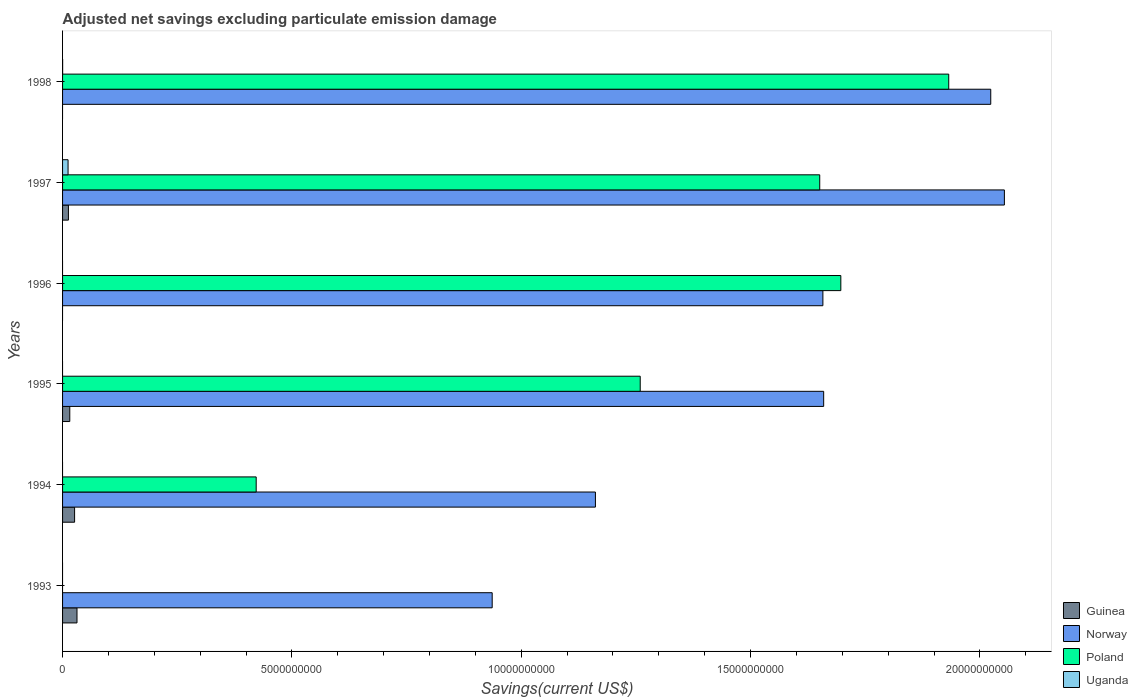Are the number of bars per tick equal to the number of legend labels?
Your answer should be compact. No. Are the number of bars on each tick of the Y-axis equal?
Offer a terse response. No. What is the label of the 1st group of bars from the top?
Keep it short and to the point. 1998. What is the adjusted net savings in Norway in 1996?
Make the answer very short. 1.66e+1. Across all years, what is the maximum adjusted net savings in Uganda?
Keep it short and to the point. 1.20e+08. Across all years, what is the minimum adjusted net savings in Guinea?
Offer a very short reply. 0. In which year was the adjusted net savings in Poland maximum?
Offer a terse response. 1998. What is the total adjusted net savings in Norway in the graph?
Your answer should be very brief. 9.49e+1. What is the difference between the adjusted net savings in Norway in 1994 and that in 1997?
Give a very brief answer. -8.92e+09. What is the difference between the adjusted net savings in Guinea in 1994 and the adjusted net savings in Norway in 1996?
Your answer should be compact. -1.63e+1. What is the average adjusted net savings in Norway per year?
Your response must be concise. 1.58e+1. In the year 1997, what is the difference between the adjusted net savings in Norway and adjusted net savings in Poland?
Your response must be concise. 4.03e+09. What is the ratio of the adjusted net savings in Norway in 1994 to that in 1996?
Give a very brief answer. 0.7. Is the adjusted net savings in Norway in 1994 less than that in 1996?
Ensure brevity in your answer.  Yes. What is the difference between the highest and the second highest adjusted net savings in Guinea?
Ensure brevity in your answer.  5.23e+07. What is the difference between the highest and the lowest adjusted net savings in Uganda?
Your answer should be very brief. 1.20e+08. Is the sum of the adjusted net savings in Guinea in 1994 and 1997 greater than the maximum adjusted net savings in Uganda across all years?
Provide a short and direct response. Yes. Is it the case that in every year, the sum of the adjusted net savings in Uganda and adjusted net savings in Guinea is greater than the sum of adjusted net savings in Poland and adjusted net savings in Norway?
Your response must be concise. No. Is it the case that in every year, the sum of the adjusted net savings in Poland and adjusted net savings in Uganda is greater than the adjusted net savings in Guinea?
Provide a short and direct response. No. Are all the bars in the graph horizontal?
Offer a very short reply. Yes. Does the graph contain any zero values?
Your response must be concise. Yes. What is the title of the graph?
Your response must be concise. Adjusted net savings excluding particulate emission damage. Does "Europe(developing only)" appear as one of the legend labels in the graph?
Keep it short and to the point. No. What is the label or title of the X-axis?
Your answer should be compact. Savings(current US$). What is the Savings(current US$) of Guinea in 1993?
Provide a succinct answer. 3.15e+08. What is the Savings(current US$) in Norway in 1993?
Offer a very short reply. 9.37e+09. What is the Savings(current US$) in Poland in 1993?
Keep it short and to the point. 0. What is the Savings(current US$) of Uganda in 1993?
Your answer should be compact. 0. What is the Savings(current US$) of Guinea in 1994?
Make the answer very short. 2.62e+08. What is the Savings(current US$) in Norway in 1994?
Provide a succinct answer. 1.16e+1. What is the Savings(current US$) of Poland in 1994?
Your answer should be very brief. 4.22e+09. What is the Savings(current US$) of Uganda in 1994?
Provide a succinct answer. 0. What is the Savings(current US$) of Guinea in 1995?
Provide a short and direct response. 1.57e+08. What is the Savings(current US$) in Norway in 1995?
Ensure brevity in your answer.  1.66e+1. What is the Savings(current US$) in Poland in 1995?
Keep it short and to the point. 1.26e+1. What is the Savings(current US$) of Uganda in 1995?
Provide a succinct answer. 0. What is the Savings(current US$) of Norway in 1996?
Your response must be concise. 1.66e+1. What is the Savings(current US$) of Poland in 1996?
Your answer should be compact. 1.70e+1. What is the Savings(current US$) in Guinea in 1997?
Provide a short and direct response. 1.28e+08. What is the Savings(current US$) of Norway in 1997?
Provide a short and direct response. 2.05e+1. What is the Savings(current US$) in Poland in 1997?
Offer a very short reply. 1.65e+1. What is the Savings(current US$) of Uganda in 1997?
Your response must be concise. 1.20e+08. What is the Savings(current US$) in Guinea in 1998?
Ensure brevity in your answer.  0. What is the Savings(current US$) of Norway in 1998?
Offer a very short reply. 2.02e+1. What is the Savings(current US$) of Poland in 1998?
Provide a succinct answer. 1.93e+1. What is the Savings(current US$) in Uganda in 1998?
Provide a succinct answer. 1.28e+06. Across all years, what is the maximum Savings(current US$) of Guinea?
Keep it short and to the point. 3.15e+08. Across all years, what is the maximum Savings(current US$) in Norway?
Make the answer very short. 2.05e+1. Across all years, what is the maximum Savings(current US$) of Poland?
Ensure brevity in your answer.  1.93e+1. Across all years, what is the maximum Savings(current US$) in Uganda?
Offer a terse response. 1.20e+08. Across all years, what is the minimum Savings(current US$) in Norway?
Keep it short and to the point. 9.37e+09. Across all years, what is the minimum Savings(current US$) of Poland?
Offer a very short reply. 0. Across all years, what is the minimum Savings(current US$) of Uganda?
Give a very brief answer. 0. What is the total Savings(current US$) in Guinea in the graph?
Provide a succinct answer. 8.62e+08. What is the total Savings(current US$) in Norway in the graph?
Your answer should be compact. 9.49e+1. What is the total Savings(current US$) in Poland in the graph?
Give a very brief answer. 6.96e+1. What is the total Savings(current US$) in Uganda in the graph?
Your answer should be very brief. 1.21e+08. What is the difference between the Savings(current US$) in Guinea in 1993 and that in 1994?
Make the answer very short. 5.23e+07. What is the difference between the Savings(current US$) of Norway in 1993 and that in 1994?
Ensure brevity in your answer.  -2.25e+09. What is the difference between the Savings(current US$) in Guinea in 1993 and that in 1995?
Make the answer very short. 1.57e+08. What is the difference between the Savings(current US$) of Norway in 1993 and that in 1995?
Your response must be concise. -7.23e+09. What is the difference between the Savings(current US$) in Norway in 1993 and that in 1996?
Keep it short and to the point. -7.21e+09. What is the difference between the Savings(current US$) in Guinea in 1993 and that in 1997?
Your answer should be very brief. 1.87e+08. What is the difference between the Savings(current US$) in Norway in 1993 and that in 1997?
Your answer should be very brief. -1.12e+1. What is the difference between the Savings(current US$) in Norway in 1993 and that in 1998?
Provide a succinct answer. -1.09e+1. What is the difference between the Savings(current US$) in Guinea in 1994 and that in 1995?
Make the answer very short. 1.05e+08. What is the difference between the Savings(current US$) in Norway in 1994 and that in 1995?
Offer a very short reply. -4.98e+09. What is the difference between the Savings(current US$) in Poland in 1994 and that in 1995?
Ensure brevity in your answer.  -8.37e+09. What is the difference between the Savings(current US$) of Norway in 1994 and that in 1996?
Provide a short and direct response. -4.96e+09. What is the difference between the Savings(current US$) in Poland in 1994 and that in 1996?
Ensure brevity in your answer.  -1.27e+1. What is the difference between the Savings(current US$) in Guinea in 1994 and that in 1997?
Provide a succinct answer. 1.35e+08. What is the difference between the Savings(current US$) in Norway in 1994 and that in 1997?
Make the answer very short. -8.92e+09. What is the difference between the Savings(current US$) of Poland in 1994 and that in 1997?
Offer a very short reply. -1.23e+1. What is the difference between the Savings(current US$) in Norway in 1994 and that in 1998?
Your answer should be very brief. -8.62e+09. What is the difference between the Savings(current US$) in Poland in 1994 and that in 1998?
Keep it short and to the point. -1.51e+1. What is the difference between the Savings(current US$) of Norway in 1995 and that in 1996?
Ensure brevity in your answer.  1.71e+07. What is the difference between the Savings(current US$) in Poland in 1995 and that in 1996?
Offer a terse response. -4.37e+09. What is the difference between the Savings(current US$) in Guinea in 1995 and that in 1997?
Provide a succinct answer. 2.96e+07. What is the difference between the Savings(current US$) in Norway in 1995 and that in 1997?
Ensure brevity in your answer.  -3.94e+09. What is the difference between the Savings(current US$) in Poland in 1995 and that in 1997?
Ensure brevity in your answer.  -3.91e+09. What is the difference between the Savings(current US$) in Norway in 1995 and that in 1998?
Your answer should be very brief. -3.64e+09. What is the difference between the Savings(current US$) of Poland in 1995 and that in 1998?
Your response must be concise. -6.73e+09. What is the difference between the Savings(current US$) in Norway in 1996 and that in 1997?
Keep it short and to the point. -3.96e+09. What is the difference between the Savings(current US$) in Poland in 1996 and that in 1997?
Offer a terse response. 4.60e+08. What is the difference between the Savings(current US$) in Norway in 1996 and that in 1998?
Offer a terse response. -3.66e+09. What is the difference between the Savings(current US$) of Poland in 1996 and that in 1998?
Provide a succinct answer. -2.35e+09. What is the difference between the Savings(current US$) in Norway in 1997 and that in 1998?
Make the answer very short. 2.97e+08. What is the difference between the Savings(current US$) of Poland in 1997 and that in 1998?
Your response must be concise. -2.81e+09. What is the difference between the Savings(current US$) of Uganda in 1997 and that in 1998?
Your response must be concise. 1.18e+08. What is the difference between the Savings(current US$) in Guinea in 1993 and the Savings(current US$) in Norway in 1994?
Provide a short and direct response. -1.13e+1. What is the difference between the Savings(current US$) of Guinea in 1993 and the Savings(current US$) of Poland in 1994?
Make the answer very short. -3.91e+09. What is the difference between the Savings(current US$) of Norway in 1993 and the Savings(current US$) of Poland in 1994?
Keep it short and to the point. 5.15e+09. What is the difference between the Savings(current US$) of Guinea in 1993 and the Savings(current US$) of Norway in 1995?
Give a very brief answer. -1.63e+1. What is the difference between the Savings(current US$) in Guinea in 1993 and the Savings(current US$) in Poland in 1995?
Your response must be concise. -1.23e+1. What is the difference between the Savings(current US$) of Norway in 1993 and the Savings(current US$) of Poland in 1995?
Provide a succinct answer. -3.23e+09. What is the difference between the Savings(current US$) of Guinea in 1993 and the Savings(current US$) of Norway in 1996?
Your answer should be very brief. -1.63e+1. What is the difference between the Savings(current US$) of Guinea in 1993 and the Savings(current US$) of Poland in 1996?
Make the answer very short. -1.67e+1. What is the difference between the Savings(current US$) of Norway in 1993 and the Savings(current US$) of Poland in 1996?
Offer a very short reply. -7.60e+09. What is the difference between the Savings(current US$) of Guinea in 1993 and the Savings(current US$) of Norway in 1997?
Ensure brevity in your answer.  -2.02e+1. What is the difference between the Savings(current US$) in Guinea in 1993 and the Savings(current US$) in Poland in 1997?
Provide a succinct answer. -1.62e+1. What is the difference between the Savings(current US$) in Guinea in 1993 and the Savings(current US$) in Uganda in 1997?
Your response must be concise. 1.95e+08. What is the difference between the Savings(current US$) in Norway in 1993 and the Savings(current US$) in Poland in 1997?
Provide a short and direct response. -7.14e+09. What is the difference between the Savings(current US$) in Norway in 1993 and the Savings(current US$) in Uganda in 1997?
Your response must be concise. 9.25e+09. What is the difference between the Savings(current US$) in Guinea in 1993 and the Savings(current US$) in Norway in 1998?
Your answer should be compact. -1.99e+1. What is the difference between the Savings(current US$) in Guinea in 1993 and the Savings(current US$) in Poland in 1998?
Offer a terse response. -1.90e+1. What is the difference between the Savings(current US$) in Guinea in 1993 and the Savings(current US$) in Uganda in 1998?
Ensure brevity in your answer.  3.13e+08. What is the difference between the Savings(current US$) of Norway in 1993 and the Savings(current US$) of Poland in 1998?
Offer a terse response. -9.95e+09. What is the difference between the Savings(current US$) of Norway in 1993 and the Savings(current US$) of Uganda in 1998?
Your answer should be compact. 9.37e+09. What is the difference between the Savings(current US$) in Guinea in 1994 and the Savings(current US$) in Norway in 1995?
Provide a short and direct response. -1.63e+1. What is the difference between the Savings(current US$) of Guinea in 1994 and the Savings(current US$) of Poland in 1995?
Provide a short and direct response. -1.23e+1. What is the difference between the Savings(current US$) in Norway in 1994 and the Savings(current US$) in Poland in 1995?
Offer a terse response. -9.77e+08. What is the difference between the Savings(current US$) of Guinea in 1994 and the Savings(current US$) of Norway in 1996?
Your answer should be very brief. -1.63e+1. What is the difference between the Savings(current US$) of Guinea in 1994 and the Savings(current US$) of Poland in 1996?
Provide a short and direct response. -1.67e+1. What is the difference between the Savings(current US$) of Norway in 1994 and the Savings(current US$) of Poland in 1996?
Offer a very short reply. -5.35e+09. What is the difference between the Savings(current US$) in Guinea in 1994 and the Savings(current US$) in Norway in 1997?
Provide a succinct answer. -2.03e+1. What is the difference between the Savings(current US$) in Guinea in 1994 and the Savings(current US$) in Poland in 1997?
Ensure brevity in your answer.  -1.62e+1. What is the difference between the Savings(current US$) of Guinea in 1994 and the Savings(current US$) of Uganda in 1997?
Offer a very short reply. 1.43e+08. What is the difference between the Savings(current US$) in Norway in 1994 and the Savings(current US$) in Poland in 1997?
Keep it short and to the point. -4.89e+09. What is the difference between the Savings(current US$) of Norway in 1994 and the Savings(current US$) of Uganda in 1997?
Your answer should be compact. 1.15e+1. What is the difference between the Savings(current US$) in Poland in 1994 and the Savings(current US$) in Uganda in 1997?
Your response must be concise. 4.10e+09. What is the difference between the Savings(current US$) in Guinea in 1994 and the Savings(current US$) in Norway in 1998?
Your answer should be compact. -2.00e+1. What is the difference between the Savings(current US$) of Guinea in 1994 and the Savings(current US$) of Poland in 1998?
Offer a very short reply. -1.91e+1. What is the difference between the Savings(current US$) of Guinea in 1994 and the Savings(current US$) of Uganda in 1998?
Provide a succinct answer. 2.61e+08. What is the difference between the Savings(current US$) in Norway in 1994 and the Savings(current US$) in Poland in 1998?
Ensure brevity in your answer.  -7.70e+09. What is the difference between the Savings(current US$) of Norway in 1994 and the Savings(current US$) of Uganda in 1998?
Your answer should be very brief. 1.16e+1. What is the difference between the Savings(current US$) of Poland in 1994 and the Savings(current US$) of Uganda in 1998?
Offer a terse response. 4.22e+09. What is the difference between the Savings(current US$) of Guinea in 1995 and the Savings(current US$) of Norway in 1996?
Give a very brief answer. -1.64e+1. What is the difference between the Savings(current US$) in Guinea in 1995 and the Savings(current US$) in Poland in 1996?
Your answer should be compact. -1.68e+1. What is the difference between the Savings(current US$) in Norway in 1995 and the Savings(current US$) in Poland in 1996?
Your answer should be compact. -3.74e+08. What is the difference between the Savings(current US$) of Guinea in 1995 and the Savings(current US$) of Norway in 1997?
Your answer should be compact. -2.04e+1. What is the difference between the Savings(current US$) in Guinea in 1995 and the Savings(current US$) in Poland in 1997?
Offer a terse response. -1.64e+1. What is the difference between the Savings(current US$) in Guinea in 1995 and the Savings(current US$) in Uganda in 1997?
Provide a short and direct response. 3.76e+07. What is the difference between the Savings(current US$) of Norway in 1995 and the Savings(current US$) of Poland in 1997?
Your answer should be compact. 8.57e+07. What is the difference between the Savings(current US$) of Norway in 1995 and the Savings(current US$) of Uganda in 1997?
Keep it short and to the point. 1.65e+1. What is the difference between the Savings(current US$) of Poland in 1995 and the Savings(current US$) of Uganda in 1997?
Your answer should be very brief. 1.25e+1. What is the difference between the Savings(current US$) of Guinea in 1995 and the Savings(current US$) of Norway in 1998?
Ensure brevity in your answer.  -2.01e+1. What is the difference between the Savings(current US$) in Guinea in 1995 and the Savings(current US$) in Poland in 1998?
Your answer should be compact. -1.92e+1. What is the difference between the Savings(current US$) in Guinea in 1995 and the Savings(current US$) in Uganda in 1998?
Your response must be concise. 1.56e+08. What is the difference between the Savings(current US$) of Norway in 1995 and the Savings(current US$) of Poland in 1998?
Your answer should be compact. -2.73e+09. What is the difference between the Savings(current US$) in Norway in 1995 and the Savings(current US$) in Uganda in 1998?
Offer a terse response. 1.66e+1. What is the difference between the Savings(current US$) of Poland in 1995 and the Savings(current US$) of Uganda in 1998?
Provide a short and direct response. 1.26e+1. What is the difference between the Savings(current US$) in Norway in 1996 and the Savings(current US$) in Poland in 1997?
Give a very brief answer. 6.86e+07. What is the difference between the Savings(current US$) in Norway in 1996 and the Savings(current US$) in Uganda in 1997?
Ensure brevity in your answer.  1.65e+1. What is the difference between the Savings(current US$) of Poland in 1996 and the Savings(current US$) of Uganda in 1997?
Ensure brevity in your answer.  1.68e+1. What is the difference between the Savings(current US$) of Norway in 1996 and the Savings(current US$) of Poland in 1998?
Make the answer very short. -2.74e+09. What is the difference between the Savings(current US$) of Norway in 1996 and the Savings(current US$) of Uganda in 1998?
Your answer should be compact. 1.66e+1. What is the difference between the Savings(current US$) in Poland in 1996 and the Savings(current US$) in Uganda in 1998?
Your answer should be compact. 1.70e+1. What is the difference between the Savings(current US$) in Guinea in 1997 and the Savings(current US$) in Norway in 1998?
Make the answer very short. -2.01e+1. What is the difference between the Savings(current US$) in Guinea in 1997 and the Savings(current US$) in Poland in 1998?
Your answer should be compact. -1.92e+1. What is the difference between the Savings(current US$) of Guinea in 1997 and the Savings(current US$) of Uganda in 1998?
Your answer should be compact. 1.26e+08. What is the difference between the Savings(current US$) of Norway in 1997 and the Savings(current US$) of Poland in 1998?
Provide a succinct answer. 1.21e+09. What is the difference between the Savings(current US$) in Norway in 1997 and the Savings(current US$) in Uganda in 1998?
Offer a very short reply. 2.05e+1. What is the difference between the Savings(current US$) of Poland in 1997 and the Savings(current US$) of Uganda in 1998?
Your answer should be compact. 1.65e+1. What is the average Savings(current US$) of Guinea per year?
Make the answer very short. 1.44e+08. What is the average Savings(current US$) of Norway per year?
Provide a short and direct response. 1.58e+1. What is the average Savings(current US$) in Poland per year?
Ensure brevity in your answer.  1.16e+1. What is the average Savings(current US$) of Uganda per year?
Make the answer very short. 2.02e+07. In the year 1993, what is the difference between the Savings(current US$) of Guinea and Savings(current US$) of Norway?
Offer a very short reply. -9.05e+09. In the year 1994, what is the difference between the Savings(current US$) in Guinea and Savings(current US$) in Norway?
Offer a very short reply. -1.14e+1. In the year 1994, what is the difference between the Savings(current US$) in Guinea and Savings(current US$) in Poland?
Ensure brevity in your answer.  -3.96e+09. In the year 1994, what is the difference between the Savings(current US$) of Norway and Savings(current US$) of Poland?
Your answer should be compact. 7.40e+09. In the year 1995, what is the difference between the Savings(current US$) in Guinea and Savings(current US$) in Norway?
Your response must be concise. -1.64e+1. In the year 1995, what is the difference between the Savings(current US$) of Guinea and Savings(current US$) of Poland?
Offer a terse response. -1.24e+1. In the year 1995, what is the difference between the Savings(current US$) of Norway and Savings(current US$) of Poland?
Your answer should be very brief. 4.00e+09. In the year 1996, what is the difference between the Savings(current US$) of Norway and Savings(current US$) of Poland?
Your response must be concise. -3.91e+08. In the year 1997, what is the difference between the Savings(current US$) of Guinea and Savings(current US$) of Norway?
Make the answer very short. -2.04e+1. In the year 1997, what is the difference between the Savings(current US$) in Guinea and Savings(current US$) in Poland?
Give a very brief answer. -1.64e+1. In the year 1997, what is the difference between the Savings(current US$) in Guinea and Savings(current US$) in Uganda?
Your answer should be compact. 7.97e+06. In the year 1997, what is the difference between the Savings(current US$) of Norway and Savings(current US$) of Poland?
Provide a short and direct response. 4.03e+09. In the year 1997, what is the difference between the Savings(current US$) in Norway and Savings(current US$) in Uganda?
Keep it short and to the point. 2.04e+1. In the year 1997, what is the difference between the Savings(current US$) of Poland and Savings(current US$) of Uganda?
Your response must be concise. 1.64e+1. In the year 1998, what is the difference between the Savings(current US$) of Norway and Savings(current US$) of Poland?
Your answer should be very brief. 9.16e+08. In the year 1998, what is the difference between the Savings(current US$) of Norway and Savings(current US$) of Uganda?
Provide a short and direct response. 2.02e+1. In the year 1998, what is the difference between the Savings(current US$) of Poland and Savings(current US$) of Uganda?
Ensure brevity in your answer.  1.93e+1. What is the ratio of the Savings(current US$) of Guinea in 1993 to that in 1994?
Your answer should be very brief. 1.2. What is the ratio of the Savings(current US$) in Norway in 1993 to that in 1994?
Your answer should be compact. 0.81. What is the ratio of the Savings(current US$) in Guinea in 1993 to that in 1995?
Offer a terse response. 2. What is the ratio of the Savings(current US$) of Norway in 1993 to that in 1995?
Offer a very short reply. 0.56. What is the ratio of the Savings(current US$) of Norway in 1993 to that in 1996?
Your response must be concise. 0.57. What is the ratio of the Savings(current US$) in Guinea in 1993 to that in 1997?
Offer a very short reply. 2.46. What is the ratio of the Savings(current US$) of Norway in 1993 to that in 1997?
Provide a succinct answer. 0.46. What is the ratio of the Savings(current US$) in Norway in 1993 to that in 1998?
Make the answer very short. 0.46. What is the ratio of the Savings(current US$) of Guinea in 1994 to that in 1995?
Provide a succinct answer. 1.67. What is the ratio of the Savings(current US$) in Norway in 1994 to that in 1995?
Provide a succinct answer. 0.7. What is the ratio of the Savings(current US$) in Poland in 1994 to that in 1995?
Offer a very short reply. 0.34. What is the ratio of the Savings(current US$) of Norway in 1994 to that in 1996?
Give a very brief answer. 0.7. What is the ratio of the Savings(current US$) of Poland in 1994 to that in 1996?
Offer a very short reply. 0.25. What is the ratio of the Savings(current US$) of Guinea in 1994 to that in 1997?
Your answer should be compact. 2.05. What is the ratio of the Savings(current US$) of Norway in 1994 to that in 1997?
Offer a very short reply. 0.57. What is the ratio of the Savings(current US$) in Poland in 1994 to that in 1997?
Offer a very short reply. 0.26. What is the ratio of the Savings(current US$) of Norway in 1994 to that in 1998?
Your response must be concise. 0.57. What is the ratio of the Savings(current US$) in Poland in 1994 to that in 1998?
Your answer should be very brief. 0.22. What is the ratio of the Savings(current US$) in Norway in 1995 to that in 1996?
Give a very brief answer. 1. What is the ratio of the Savings(current US$) of Poland in 1995 to that in 1996?
Provide a short and direct response. 0.74. What is the ratio of the Savings(current US$) of Guinea in 1995 to that in 1997?
Provide a short and direct response. 1.23. What is the ratio of the Savings(current US$) in Norway in 1995 to that in 1997?
Keep it short and to the point. 0.81. What is the ratio of the Savings(current US$) in Poland in 1995 to that in 1997?
Your response must be concise. 0.76. What is the ratio of the Savings(current US$) of Norway in 1995 to that in 1998?
Provide a succinct answer. 0.82. What is the ratio of the Savings(current US$) in Poland in 1995 to that in 1998?
Offer a terse response. 0.65. What is the ratio of the Savings(current US$) in Norway in 1996 to that in 1997?
Ensure brevity in your answer.  0.81. What is the ratio of the Savings(current US$) in Poland in 1996 to that in 1997?
Your response must be concise. 1.03. What is the ratio of the Savings(current US$) in Norway in 1996 to that in 1998?
Your answer should be very brief. 0.82. What is the ratio of the Savings(current US$) in Poland in 1996 to that in 1998?
Provide a short and direct response. 0.88. What is the ratio of the Savings(current US$) of Norway in 1997 to that in 1998?
Provide a succinct answer. 1.01. What is the ratio of the Savings(current US$) of Poland in 1997 to that in 1998?
Provide a short and direct response. 0.85. What is the ratio of the Savings(current US$) of Uganda in 1997 to that in 1998?
Ensure brevity in your answer.  93.57. What is the difference between the highest and the second highest Savings(current US$) of Guinea?
Make the answer very short. 5.23e+07. What is the difference between the highest and the second highest Savings(current US$) in Norway?
Give a very brief answer. 2.97e+08. What is the difference between the highest and the second highest Savings(current US$) in Poland?
Keep it short and to the point. 2.35e+09. What is the difference between the highest and the lowest Savings(current US$) in Guinea?
Make the answer very short. 3.15e+08. What is the difference between the highest and the lowest Savings(current US$) of Norway?
Ensure brevity in your answer.  1.12e+1. What is the difference between the highest and the lowest Savings(current US$) of Poland?
Your answer should be very brief. 1.93e+1. What is the difference between the highest and the lowest Savings(current US$) in Uganda?
Your response must be concise. 1.20e+08. 